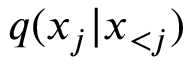<formula> <loc_0><loc_0><loc_500><loc_500>q ( x _ { j } | x _ { < j } )</formula> 